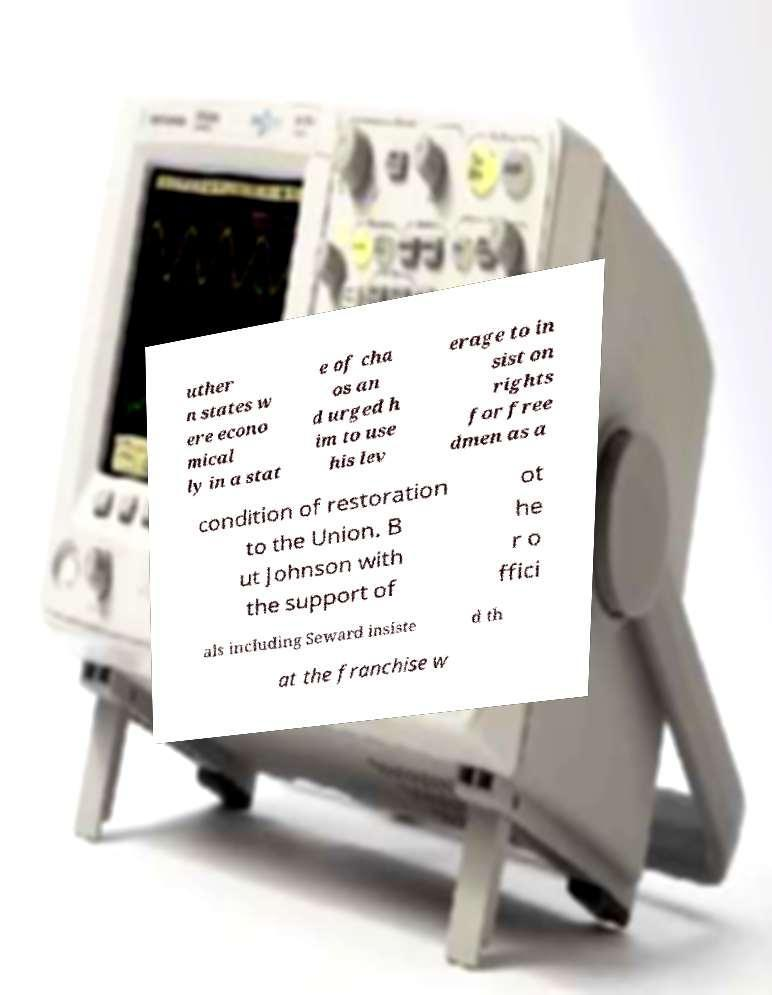Please read and relay the text visible in this image. What does it say? uther n states w ere econo mical ly in a stat e of cha os an d urged h im to use his lev erage to in sist on rights for free dmen as a condition of restoration to the Union. B ut Johnson with the support of ot he r o ffici als including Seward insiste d th at the franchise w 